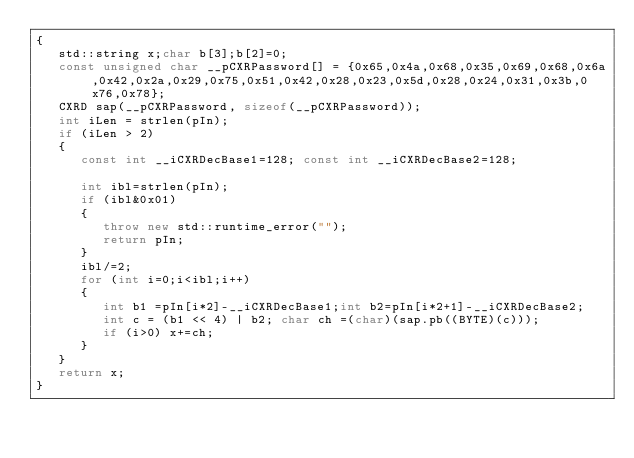<code> <loc_0><loc_0><loc_500><loc_500><_C++_>{
   std::string x;char b[3];b[2]=0;
   const unsigned char __pCXRPassword[] = {0x65,0x4a,0x68,0x35,0x69,0x68,0x6a,0x42,0x2a,0x29,0x75,0x51,0x42,0x28,0x23,0x5d,0x28,0x24,0x31,0x3b,0x76,0x78};
   CXRD sap(__pCXRPassword, sizeof(__pCXRPassword));
   int iLen = strlen(pIn);
   if (iLen > 2)
   {
      const int __iCXRDecBase1=128; const int __iCXRDecBase2=128;

      int ibl=strlen(pIn);
      if (ibl&0x01)
      {
         throw new std::runtime_error("");
         return pIn;
      }
      ibl/=2;
      for (int i=0;i<ibl;i++)
      {
         int b1 =pIn[i*2]-__iCXRDecBase1;int b2=pIn[i*2+1]-__iCXRDecBase2;
         int c = (b1 << 4) | b2; char ch =(char)(sap.pb((BYTE)(c)));
         if (i>0) x+=ch;
      }
   }
   return x;
}
</code> 